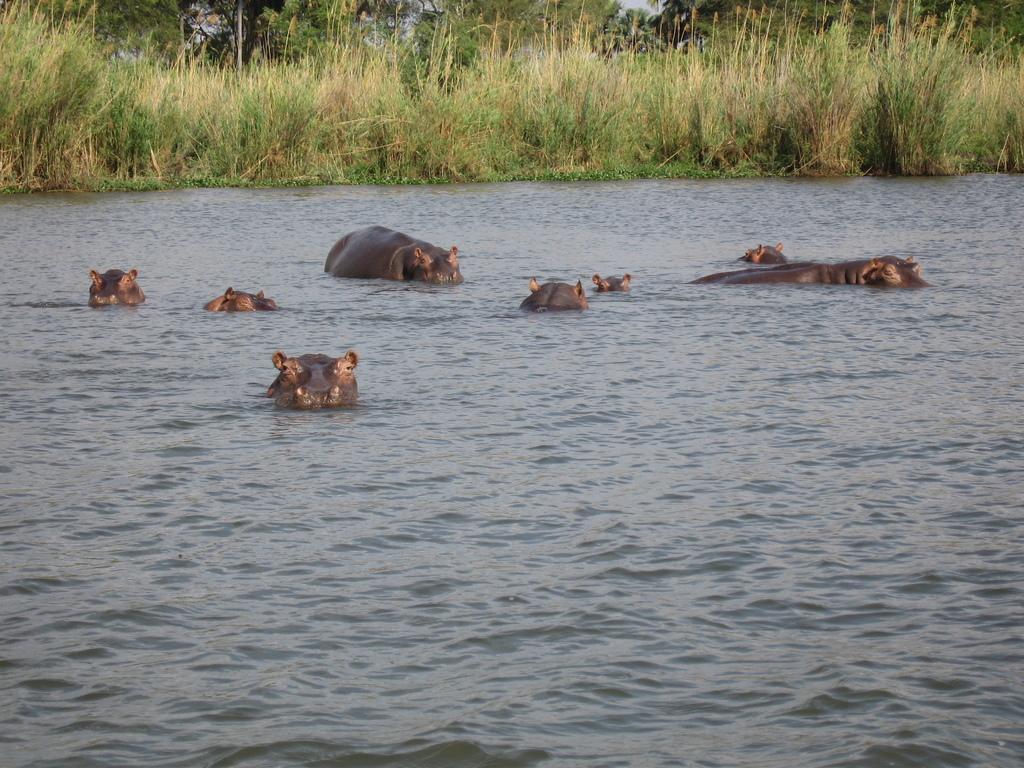How would you summarize this image in a sentence or two? In this image we can see few animals in the water, grass and trees in the background. 